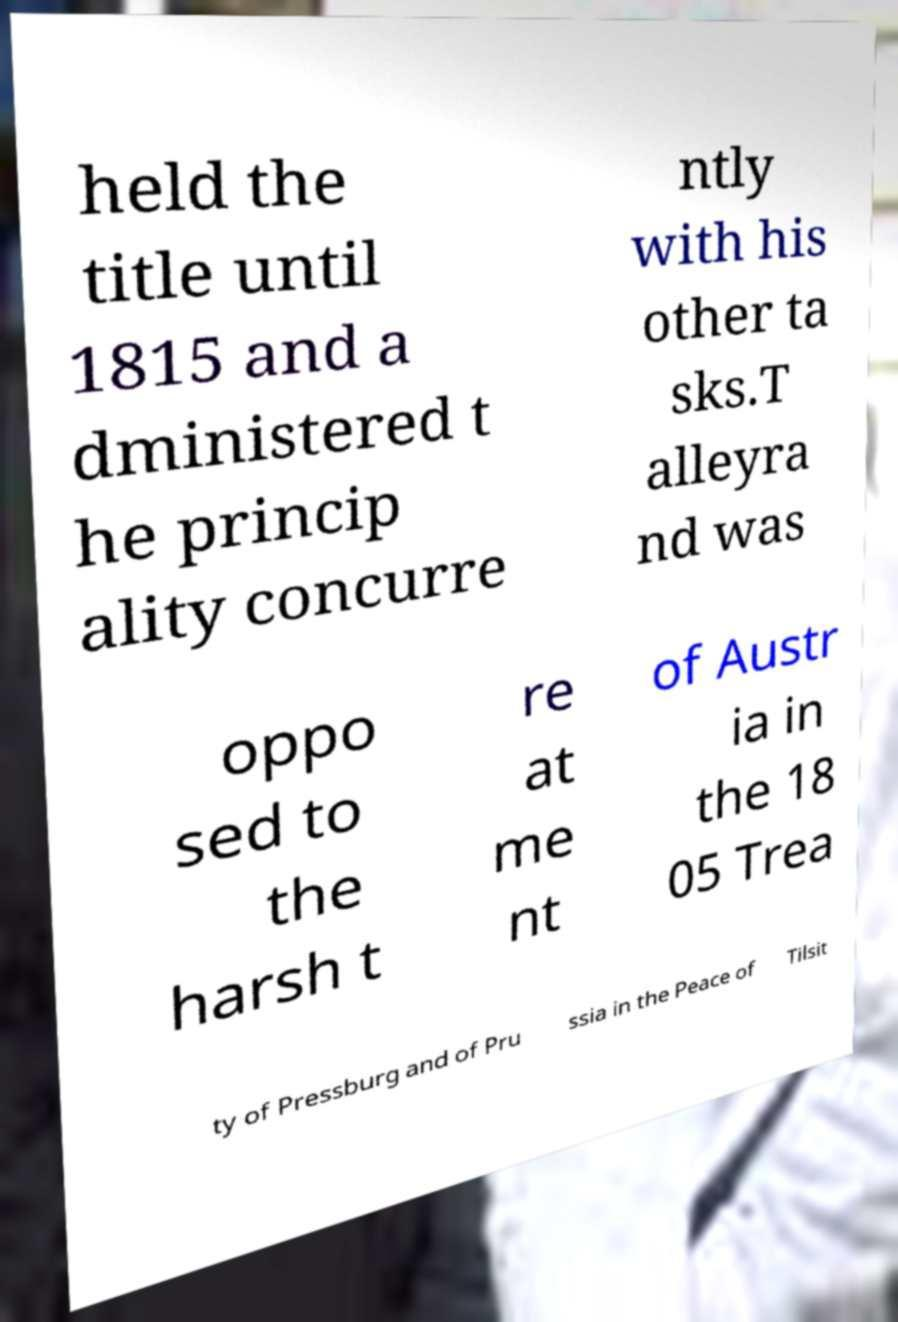Can you read and provide the text displayed in the image?This photo seems to have some interesting text. Can you extract and type it out for me? held the title until 1815 and a dministered t he princip ality concurre ntly with his other ta sks.T alleyra nd was oppo sed to the harsh t re at me nt of Austr ia in the 18 05 Trea ty of Pressburg and of Pru ssia in the Peace of Tilsit 